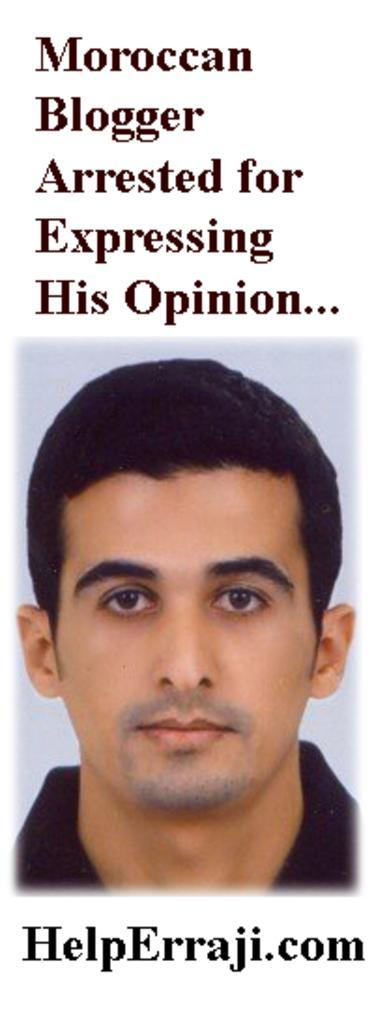Please provide a concise description of this image. This picture shows a picture of a man with text on the top and at the bottom. 